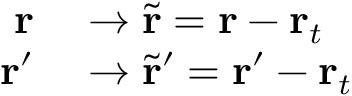Convert formula to latex. <formula><loc_0><loc_0><loc_500><loc_500>\begin{array} { r l } { r } & \rightarrow \tilde { r } = r - r _ { t } } \\ { r ^ { \prime } } & \rightarrow \tilde { r } ^ { \prime } = r ^ { \prime } - r _ { t } } \end{array}</formula> 